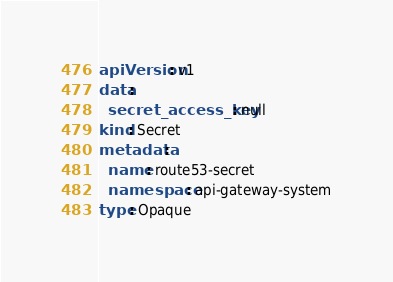Convert code to text. <code><loc_0><loc_0><loc_500><loc_500><_YAML_>apiVersion: v1
data:
  secret_access_key: null
kind: Secret
metadata:
  name: route53-secret
  namespace: api-gateway-system
type: Opaque</code> 